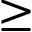Convert formula to latex. <formula><loc_0><loc_0><loc_500><loc_500>\geq</formula> 